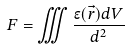<formula> <loc_0><loc_0><loc_500><loc_500>F = \iiint \frac { \epsilon ( \vec { r } ) d V } { d ^ { 2 } }</formula> 